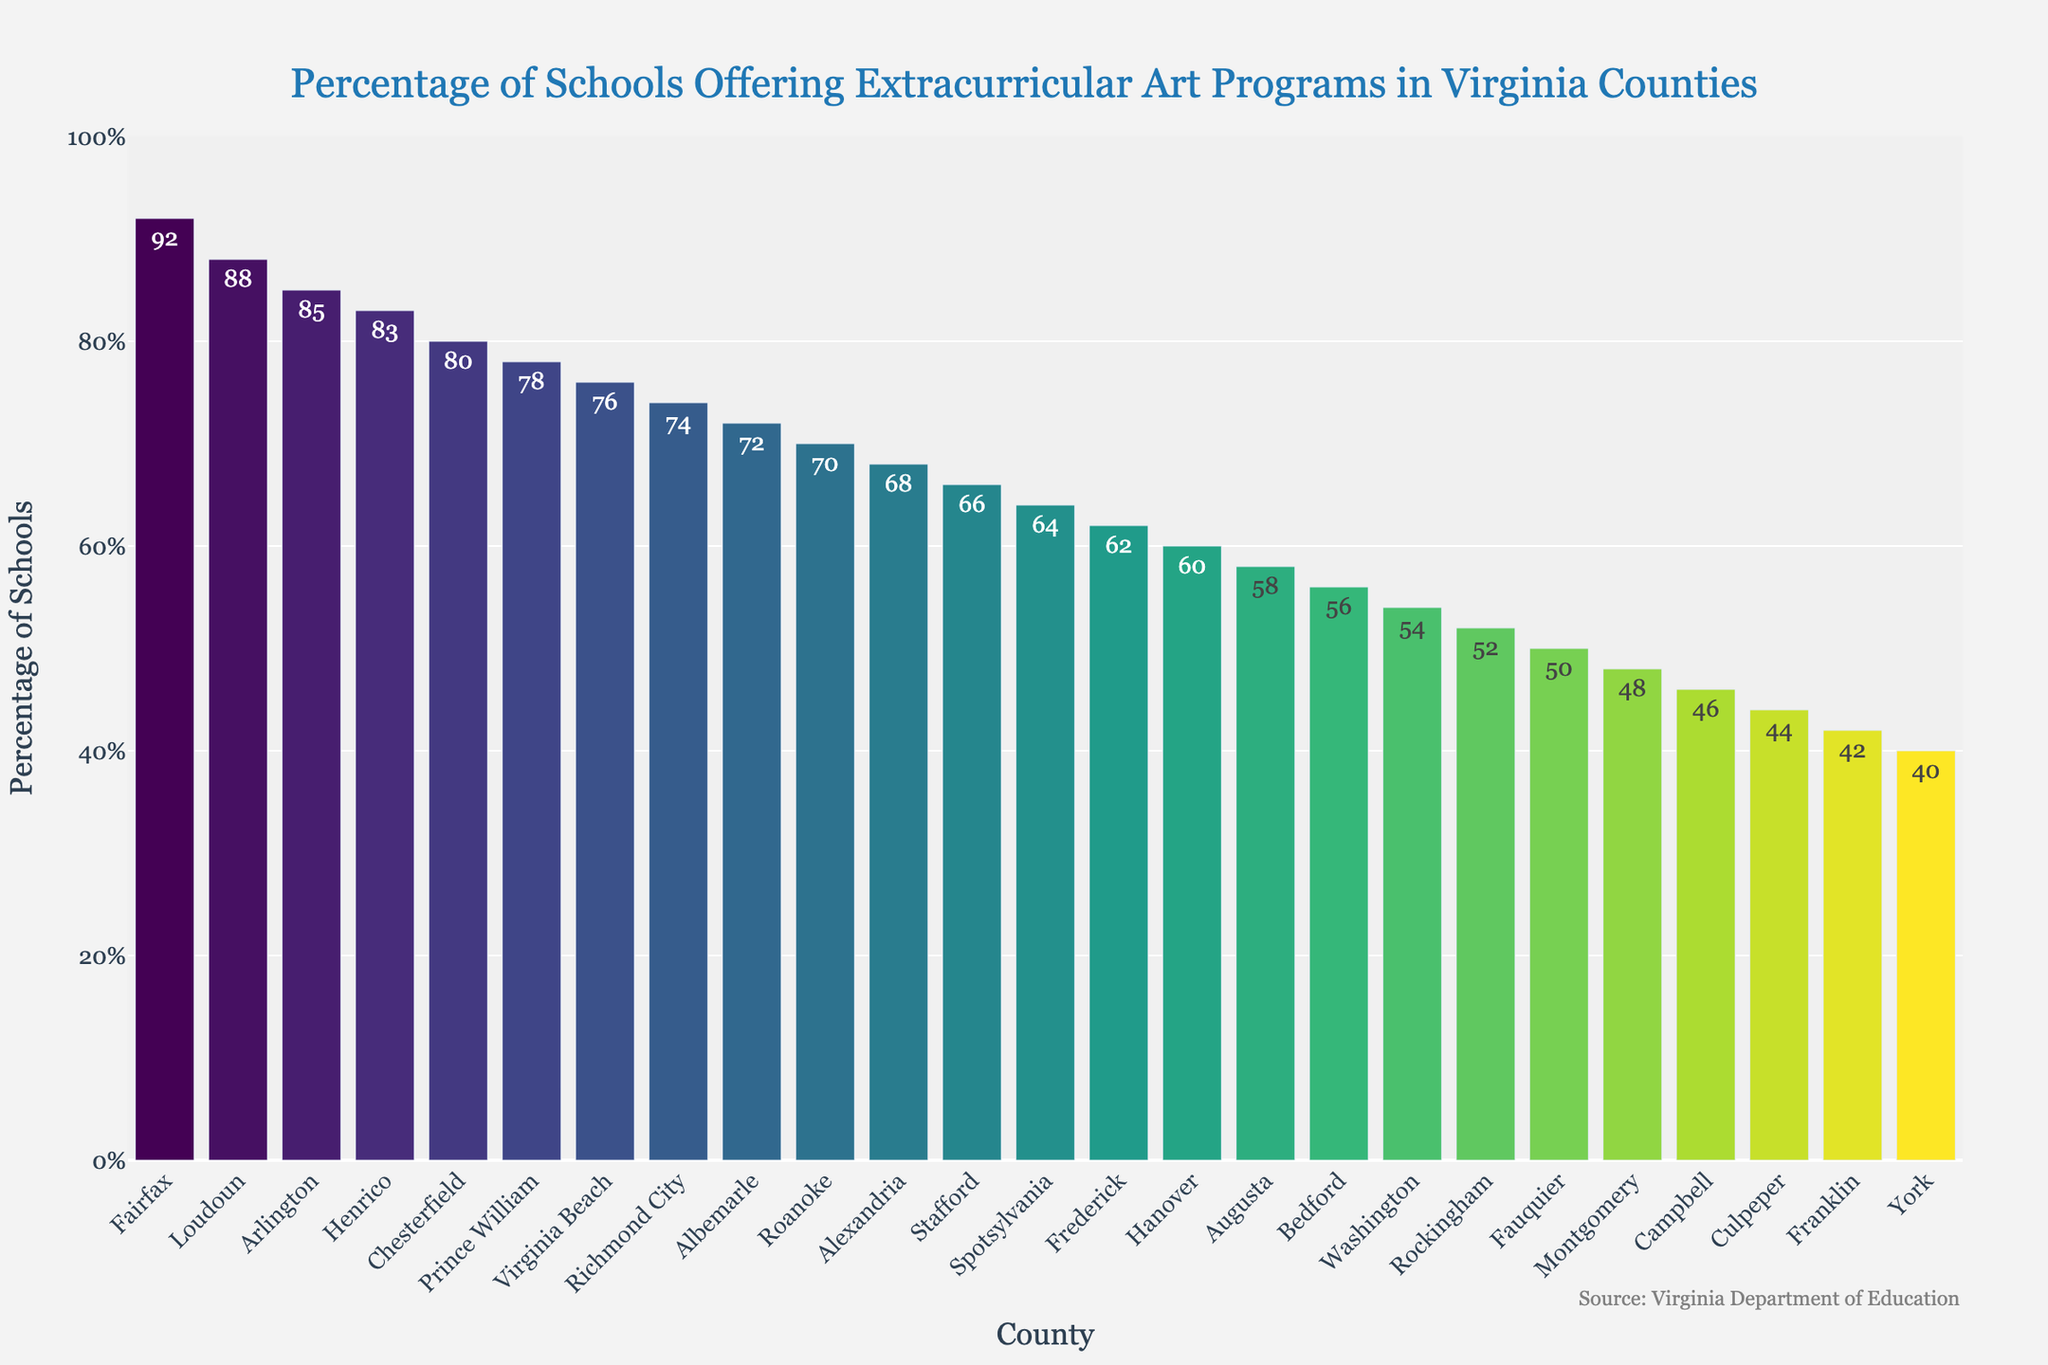Which county has the highest percentage of schools offering extracurricular art programs? Look for the tallest bar in the chart. The tallest bar corresponds to Fairfax County.
Answer: Fairfax Which county has the lowest percentage of schools offering extracurricular art programs? Look for the shortest bar in the chart. The shortest bar corresponds to York County.
Answer: York What is the percentage difference between Fairfax and York counties? The percentage of Fairfax is 92%, and York is 40%. The difference is calculated as 92 - 40 = 52%.
Answer: 52% How many counties have more than 80% of schools offering extracurricular art programs? Count the bars where the percentage is greater than 80%. There are four bars: Fairfax, Loudoun, Arlington, and Henrico.
Answer: 4 Which counties have a percentage between 70% and 80%? Identify bars with percentages in the range of 70% to 80%. They are Virginia Beach (76%), Richmond City (74%), Albemarle (72%), and Roanoke (70%).
Answer: Virginia Beach, Richmond City, Albemarle, Roanoke What is the average percentage of schools offering extracurricular art programs in the top 5 counties? First, identify the top 5 counties (Fairfax, Loudoun, Arlington, Henrico, Chesterfield) with percentages 92, 88, 85, 83, and 80 respectively. Calculate the average: (92 + 88 + 85 + 83 + 80) / 5 = 85.6%.
Answer: 85.6 Is the percentage of schools offering extracurricular art programs higher in Fairfax County compared to Prince William County? The percentage for Fairfax is 92%, and for Prince William is 78%. Compare the two values: 92% > 78%.
Answer: Yes What is the percentage range for the counties listed on the chart? Identify the maximum percentage (92% for Fairfax) and the minimum percentage (40% for York). The range is 92% - 40% = 52%.
Answer: 52 How many counties fall below the median percentage value in this chart? First, sort the counties by percentage. The median falls between the 13th and 14th counties (Alexandria and Franklin, with 68% and 42%). Count how many have percentages less than 55%. There are 13 counties below this percentage.
Answer: 13 Which counties have percentages that closely cluster around 60%? Identify counties with percentages close to 60%, such as Hanover (60%), Augusta (58%), and Bedford (56%).
Answer: Hanover, Augusta, Bedford 